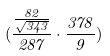Convert formula to latex. <formula><loc_0><loc_0><loc_500><loc_500>( \frac { \frac { 8 2 } { \sqrt { 3 4 3 } } } { 2 8 7 } \cdot \frac { 3 7 8 } { 9 } )</formula> 